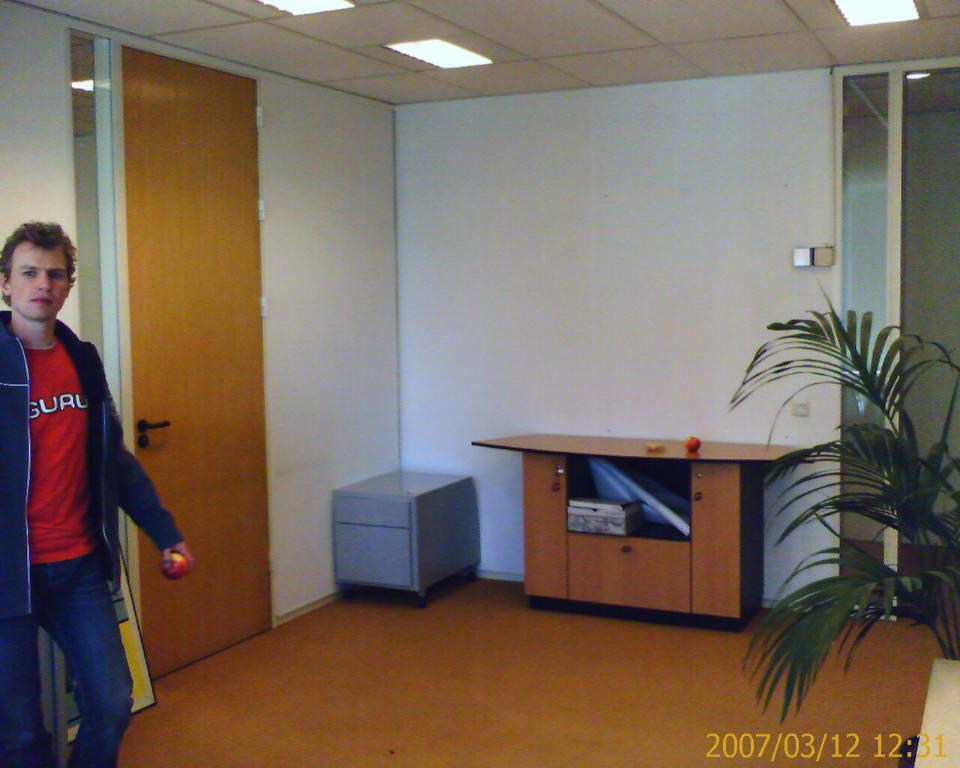What is the person in the image holding? The person is standing and holding a ball. What piece of furniture can be seen in the image? There is a table in the image. What type of plant is on the floor? There is a plant on the floor. What is on top of the table? There are objects on the table. What is behind the person? There is a wall behind the person. What architectural feature is in the wall? There is a door in the wall. What is visible at the top of the image? There are lights visible at the top of the image. What type of box is being used as a calculator in the image? There is no box or calculator is present in the image. 